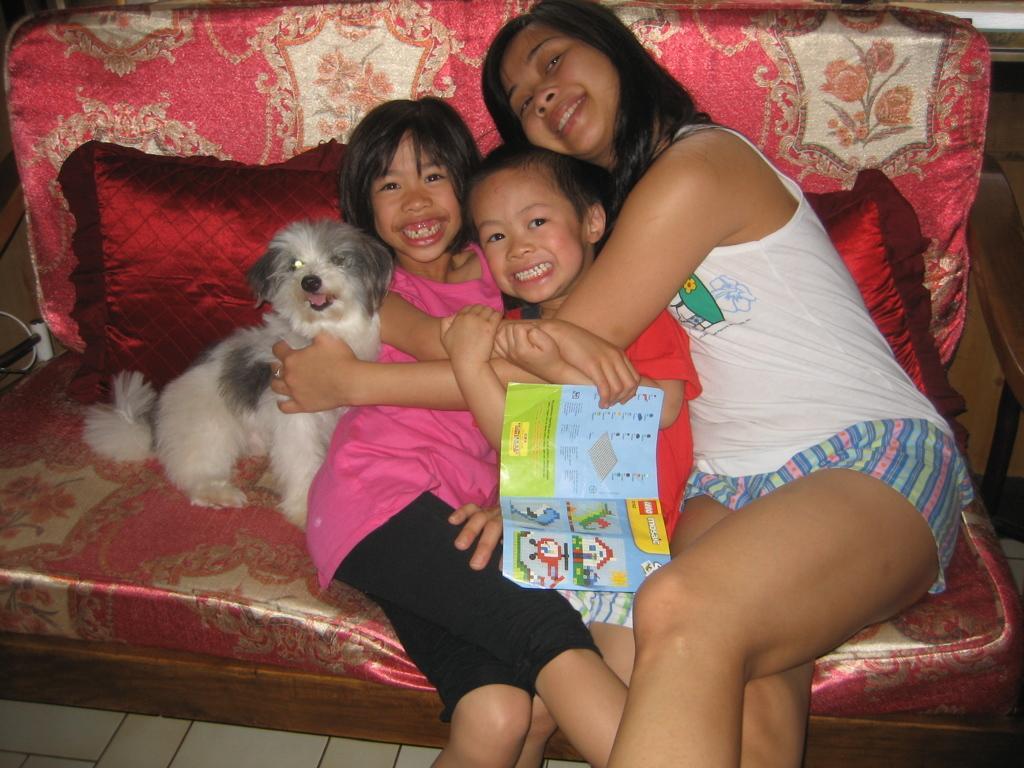Please provide a concise description of this image. There are three people and a dog are sitting on a sofa. The girl on the left side is smiling. The woman on the right side is holding two people and a dog. 